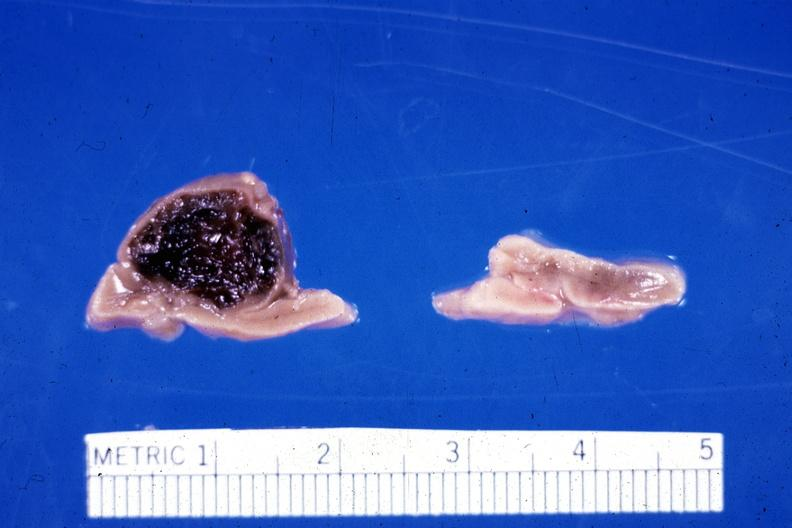what had adrenal of premature 30 week gestation gram infant lesion ruptured causing hemoperitoneum?
Answer the question using a single word or phrase. 20 